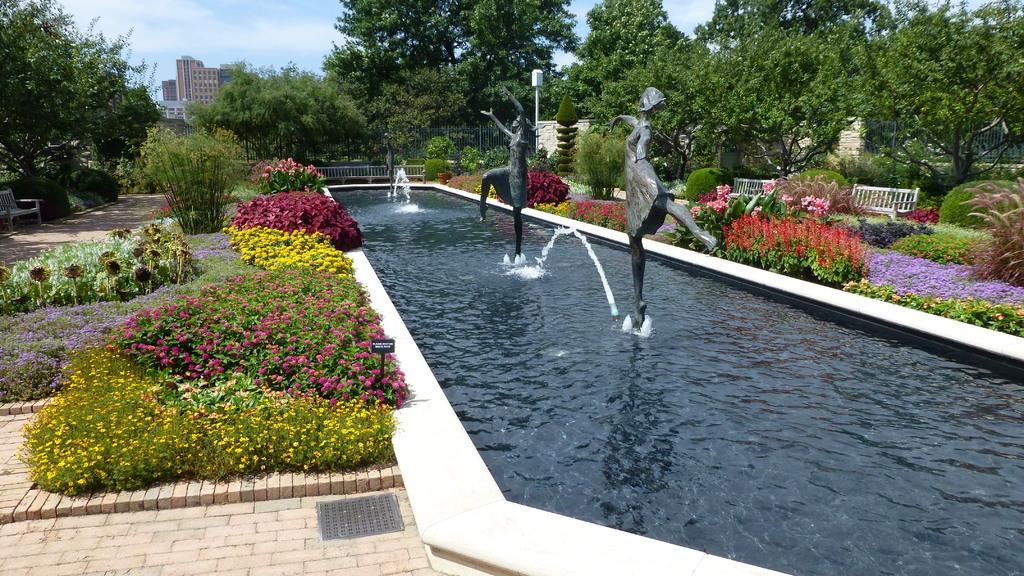Can you describe this image briefly? This is the picture of a garden. In the middle of the garden fountain is present and so many plants of different flowers is there. Behind trees are present and buildings are there, 